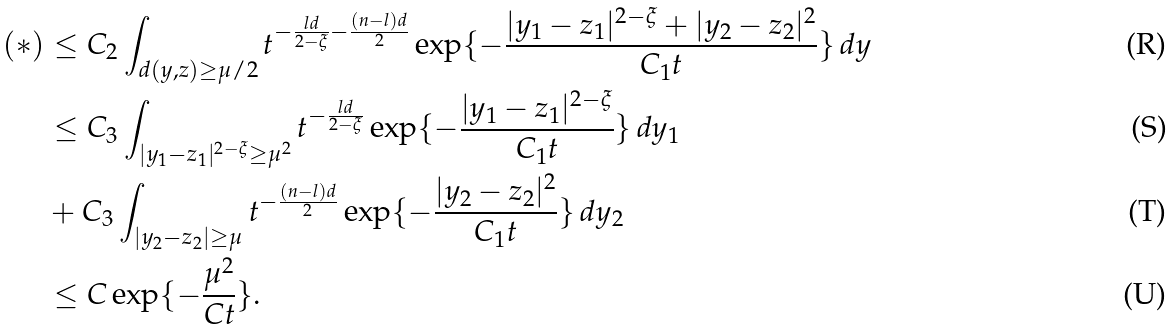<formula> <loc_0><loc_0><loc_500><loc_500>( * ) & \leq C _ { 2 } \int _ { d ( y , z ) \geq \mu / 2 } t ^ { - \frac { l d } { 2 - \xi } - \frac { ( n - l ) d } 2 } \exp \{ - \frac { | y _ { 1 } - z _ { 1 } | ^ { 2 - \xi } + | y _ { 2 } - z _ { 2 } | ^ { 2 } } { C _ { 1 } t } \} \, d y \\ & \leq C _ { 3 } \int _ { | y _ { 1 } - z _ { 1 } | ^ { 2 - \xi } \geq \mu ^ { 2 } } t ^ { - \frac { l d } { 2 - \xi } } \exp \{ - \frac { | y _ { 1 } - z _ { 1 } | ^ { 2 - \xi } } { C _ { 1 } t } \} \, d y _ { 1 } \\ & + C _ { 3 } \int _ { | y _ { 2 } - z _ { 2 } | \geq \mu } t ^ { - \frac { ( n - l ) d } 2 } \exp \{ - \frac { | y _ { 2 } - z _ { 2 } | ^ { 2 } } { C _ { 1 } t } \} \, d y _ { 2 } \\ & \leq C \exp \{ - \frac { \mu ^ { 2 } } { C t } \} .</formula> 